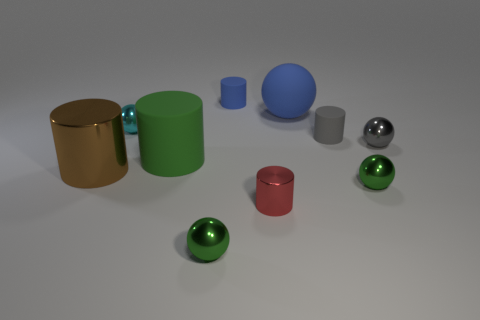There is a green metal object behind the small red object; does it have the same shape as the big object that is in front of the green matte object?
Offer a terse response. No. There is a red metallic thing that is the same size as the cyan shiny thing; what is its shape?
Your answer should be compact. Cylinder. Are there the same number of green metal things that are behind the brown thing and red cylinders in front of the big green rubber cylinder?
Ensure brevity in your answer.  No. Is the tiny green thing that is in front of the red shiny object made of the same material as the green cylinder?
Offer a very short reply. No. What material is the ball that is the same size as the green matte cylinder?
Ensure brevity in your answer.  Rubber. How many other objects are the same material as the small gray cylinder?
Your answer should be very brief. 3. Is the size of the blue cylinder the same as the matte cylinder that is to the left of the small blue matte thing?
Your answer should be compact. No. Are there fewer large brown cylinders behind the tiny gray matte thing than large cylinders that are in front of the cyan ball?
Keep it short and to the point. Yes. There is a metal cylinder left of the small blue object; what is its size?
Keep it short and to the point. Large. Do the gray sphere and the brown cylinder have the same size?
Offer a very short reply. No. 